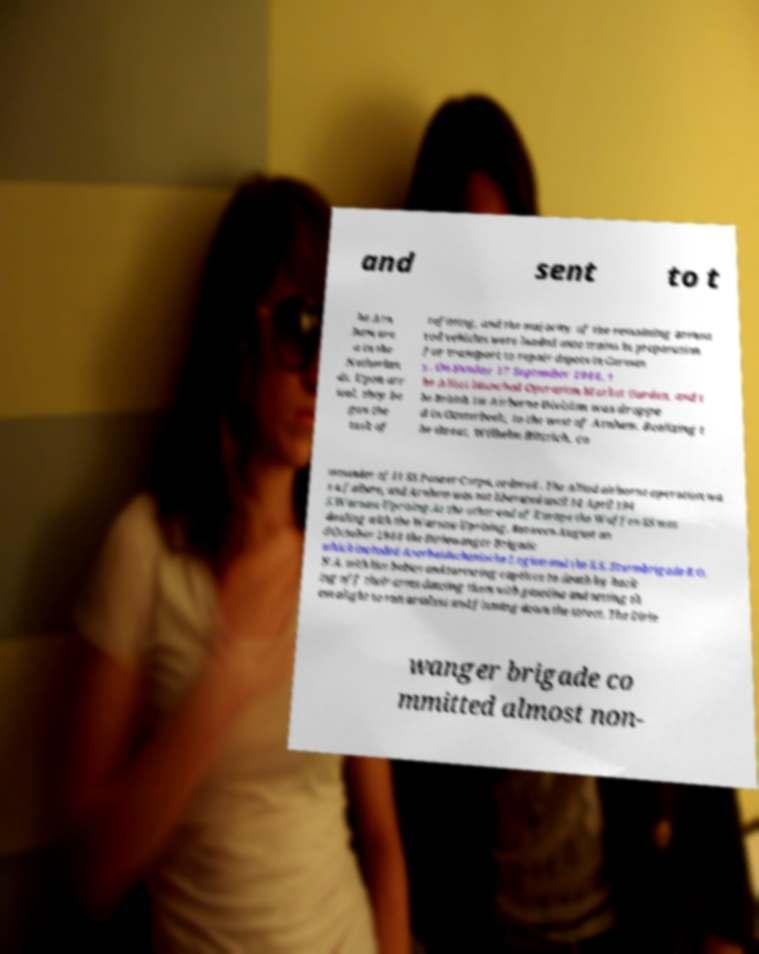Can you accurately transcribe the text from the provided image for me? and sent to t he Arn hem are a in the Netherlan ds. Upon arr ival, they be gan the task of refitting, and the majority of the remaining armou red vehicles were loaded onto trains in preparation for transport to repair depots in German y. On Sunday 17 September 1944, t he Allies launched Operation Market Garden, and t he British 1st Airborne Division was droppe d in Oosterbeek, to the west of Arnhem. Realizing t he threat, Wilhelm Bittrich, co mmander of II SS Panzer Corps, ordered . The Allied airborne operation wa s a failure, and Arnhem was not liberated until 14 April 194 5.Warsaw Uprising.At the other end of Europe the Waffen-SS was dealing with the Warsaw Uprising. Between August an d October 1944 the Dirlewanger Brigade which included Aserbaidschanische Legion and the S.S. Sturmbrigade R.O. N.A. with live babies and torturing captives to death by hack ing off their arms dousing them with gasoline and setting th em alight to run armless and flaming down the street. The Dirle wanger brigade co mmitted almost non- 